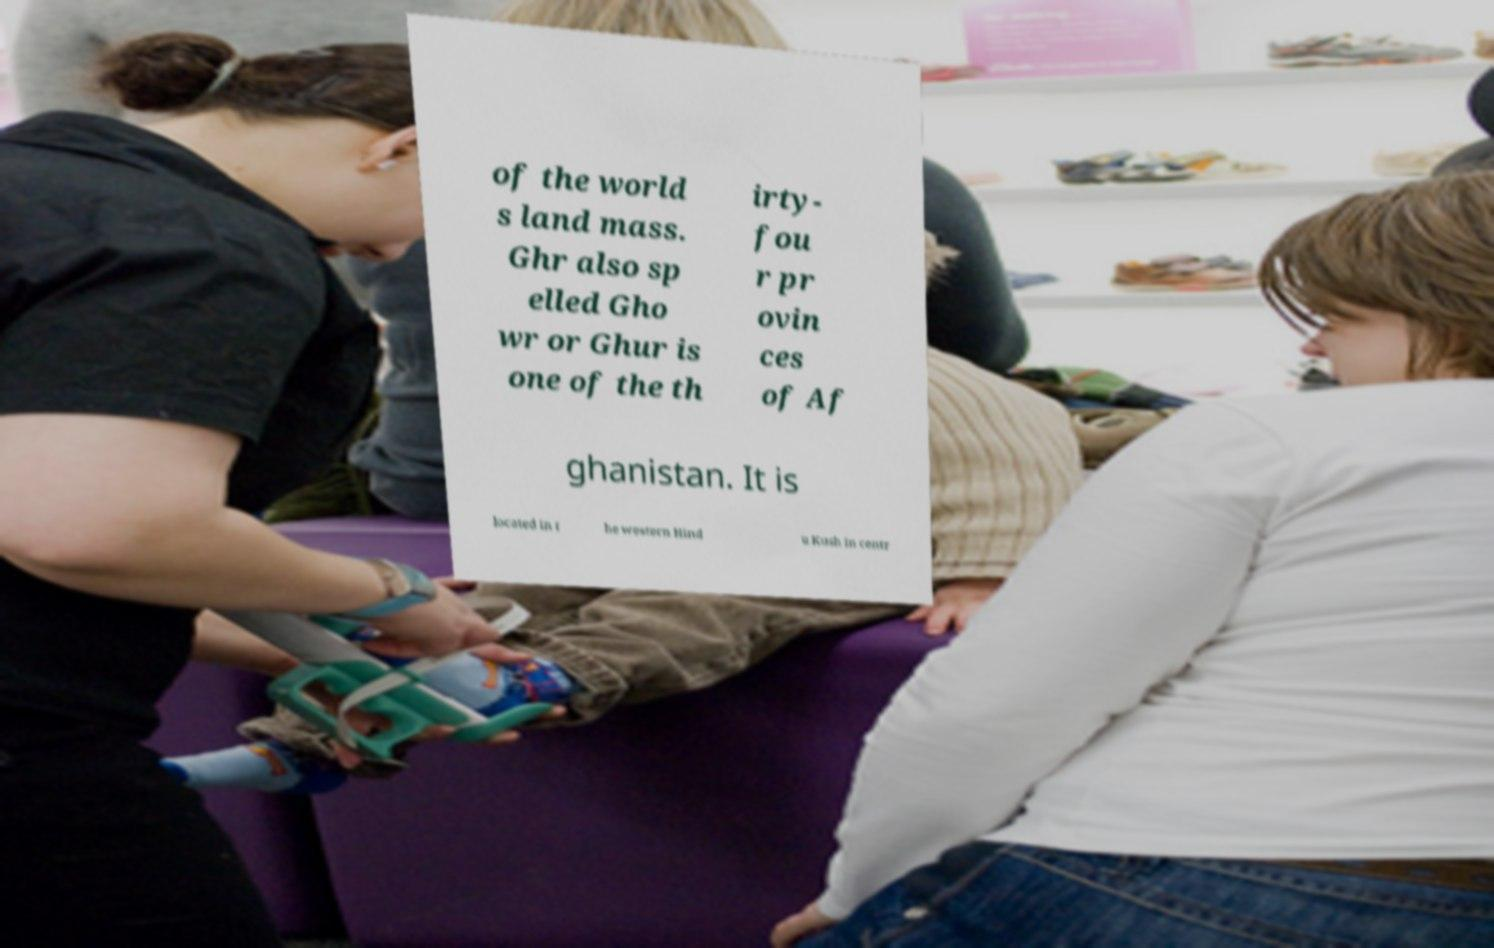What messages or text are displayed in this image? I need them in a readable, typed format. of the world s land mass. Ghr also sp elled Gho wr or Ghur is one of the th irty- fou r pr ovin ces of Af ghanistan. It is located in t he western Hind u Kush in centr 